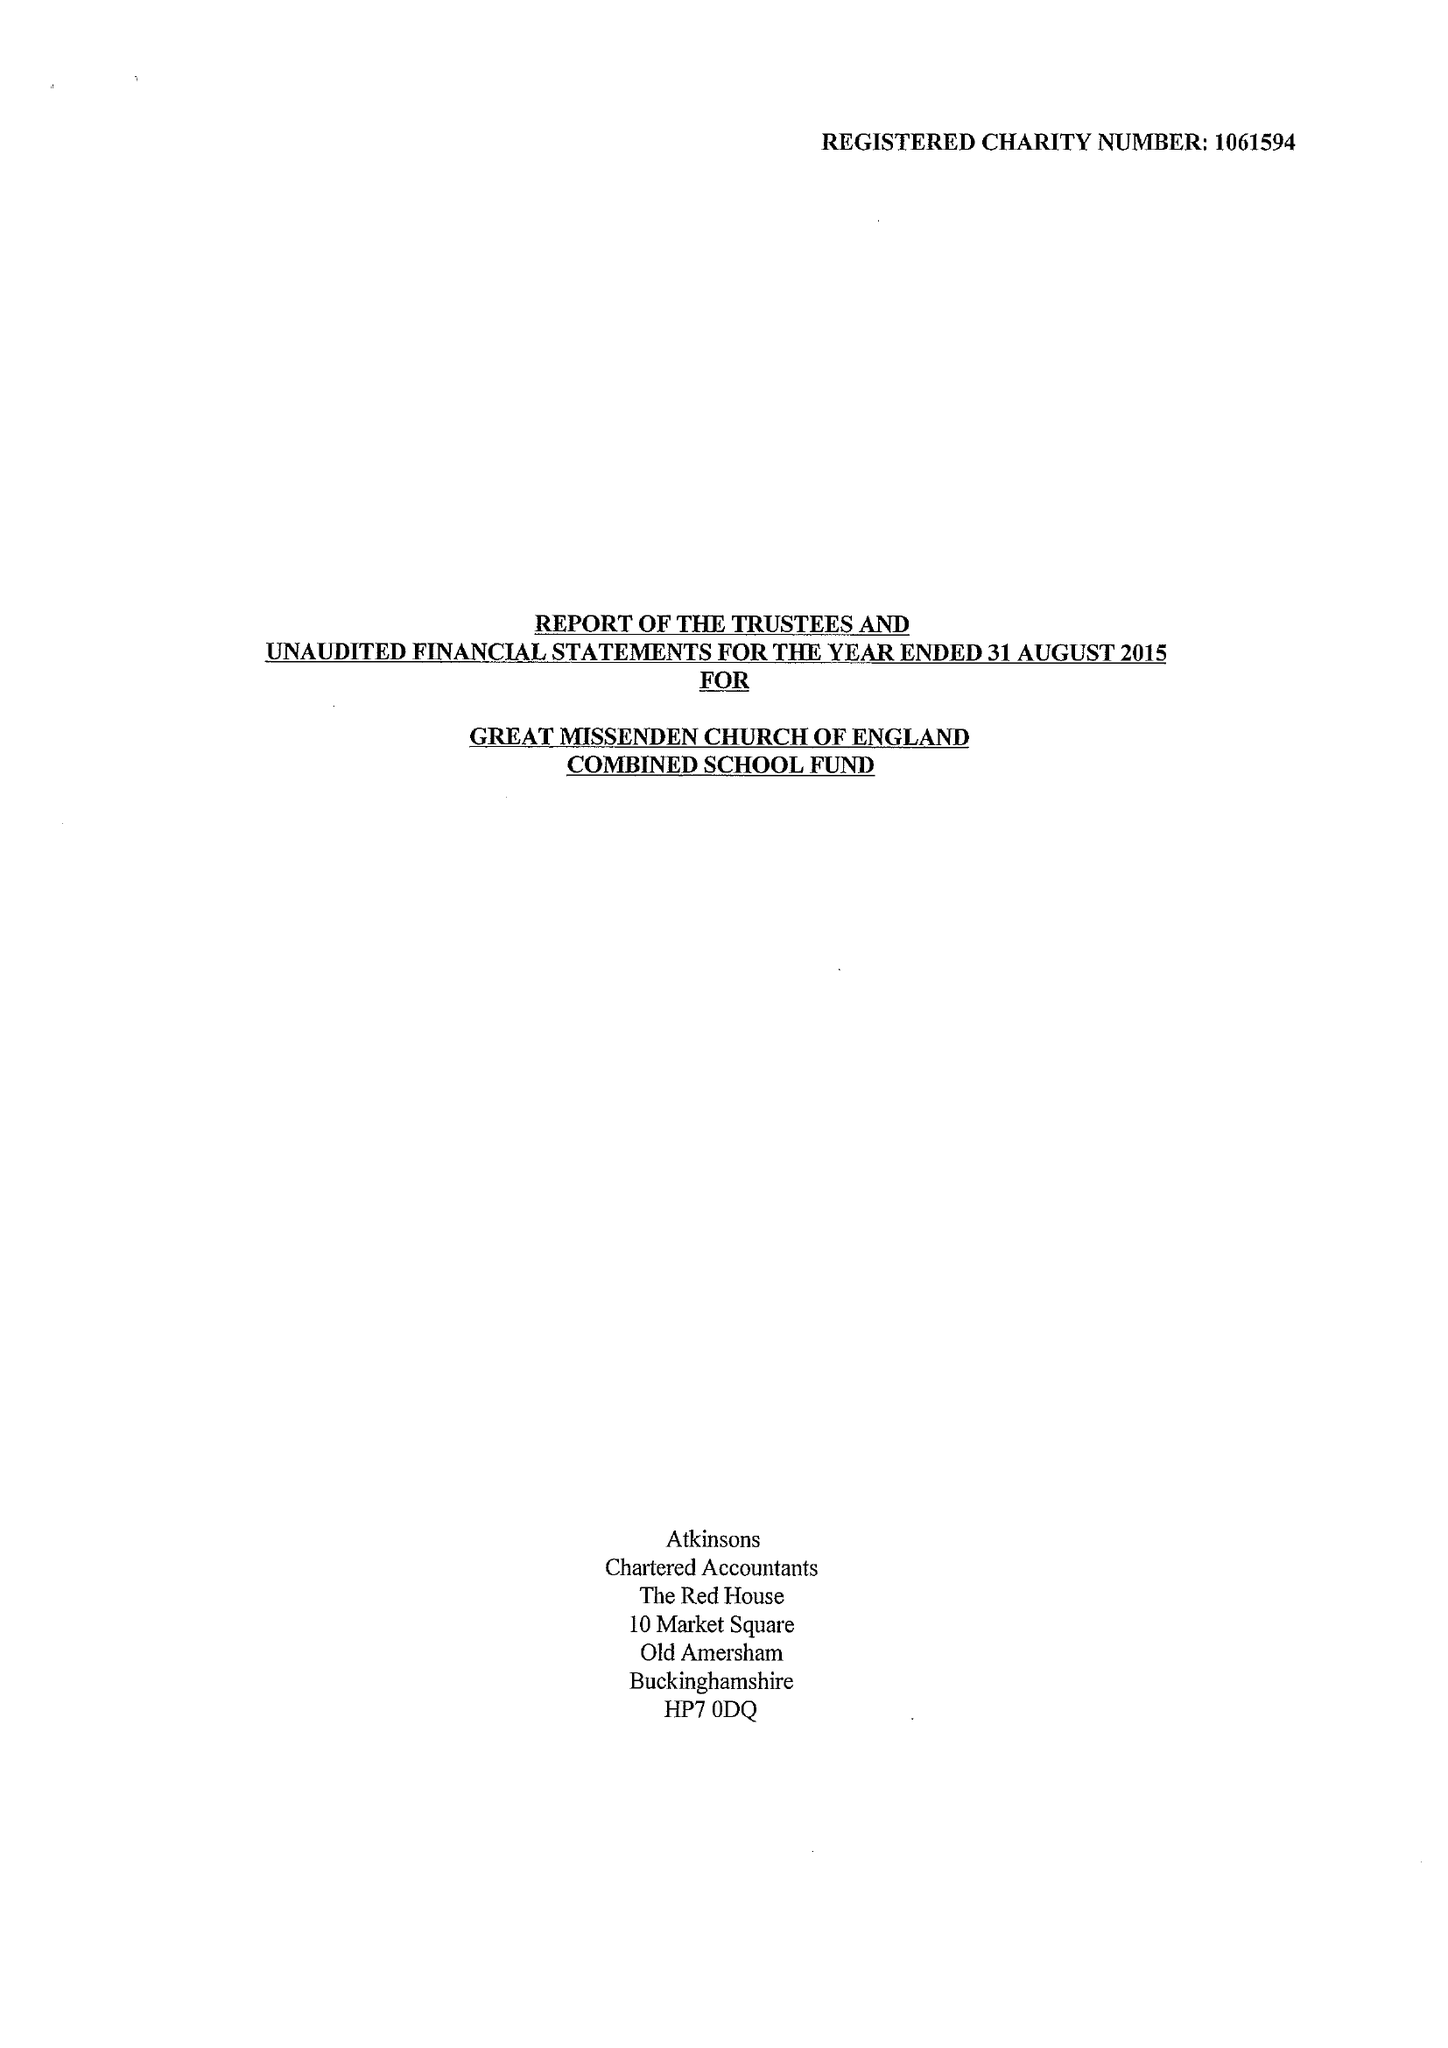What is the value for the report_date?
Answer the question using a single word or phrase. 2015-08-31 